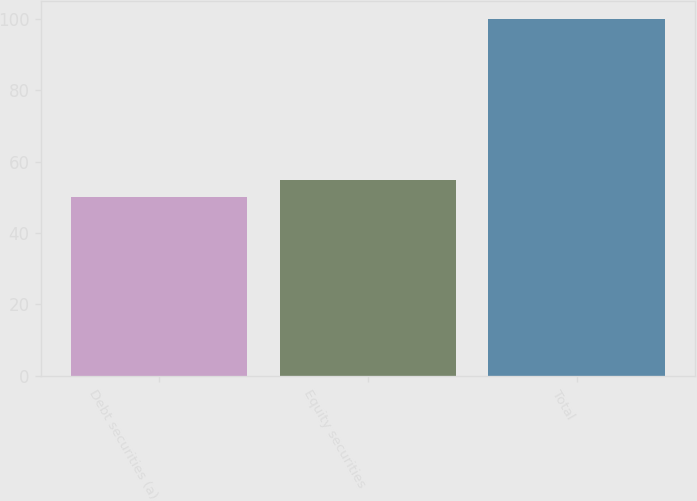<chart> <loc_0><loc_0><loc_500><loc_500><bar_chart><fcel>Debt securities (a)<fcel>Equity securities<fcel>Total<nl><fcel>50<fcel>55<fcel>100<nl></chart> 